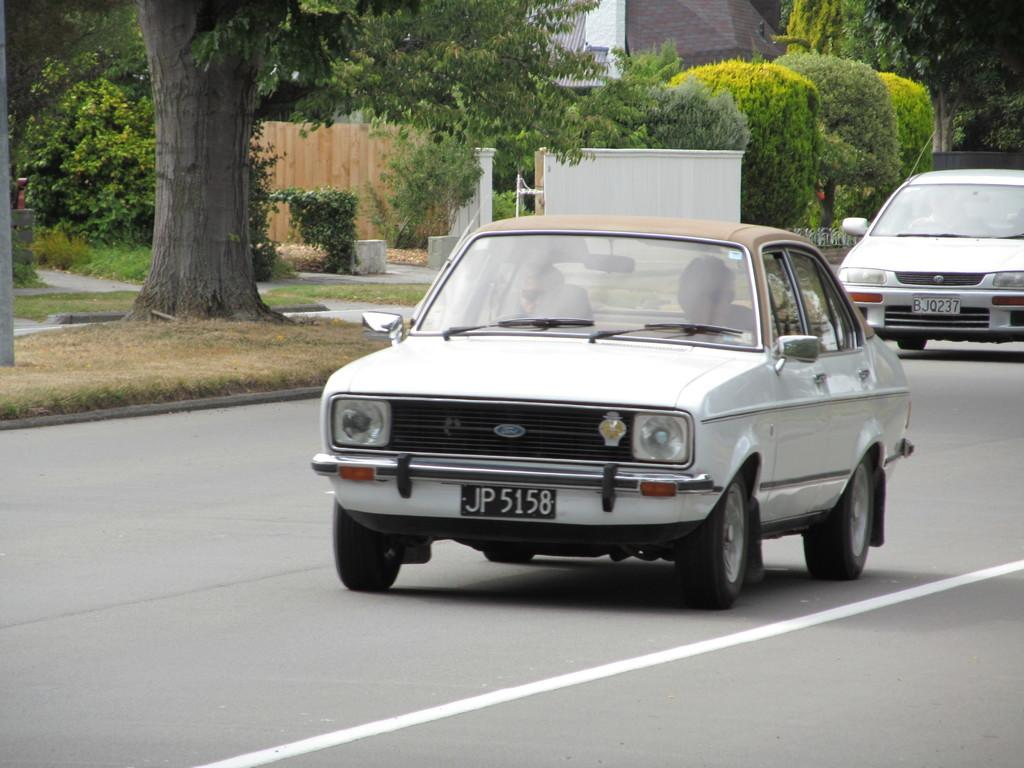How many persons are in the cars in the image? There are two persons in the cars in the image. Where are the cars located? The cars are on the road in the image. What type of vegetation is visible behind the cars? There are trees and grass visible behind the cars. What type of barrier is present behind the cars? There is a wooden fence behind the cars. What type of structure is visible behind the cars? There is a house behind the cars. What type of yam is being served with a fork in the image? There is no yam or fork present in the image; it features two persons in cars on the road with a background of trees, grass, a wooden fence, and a house. 